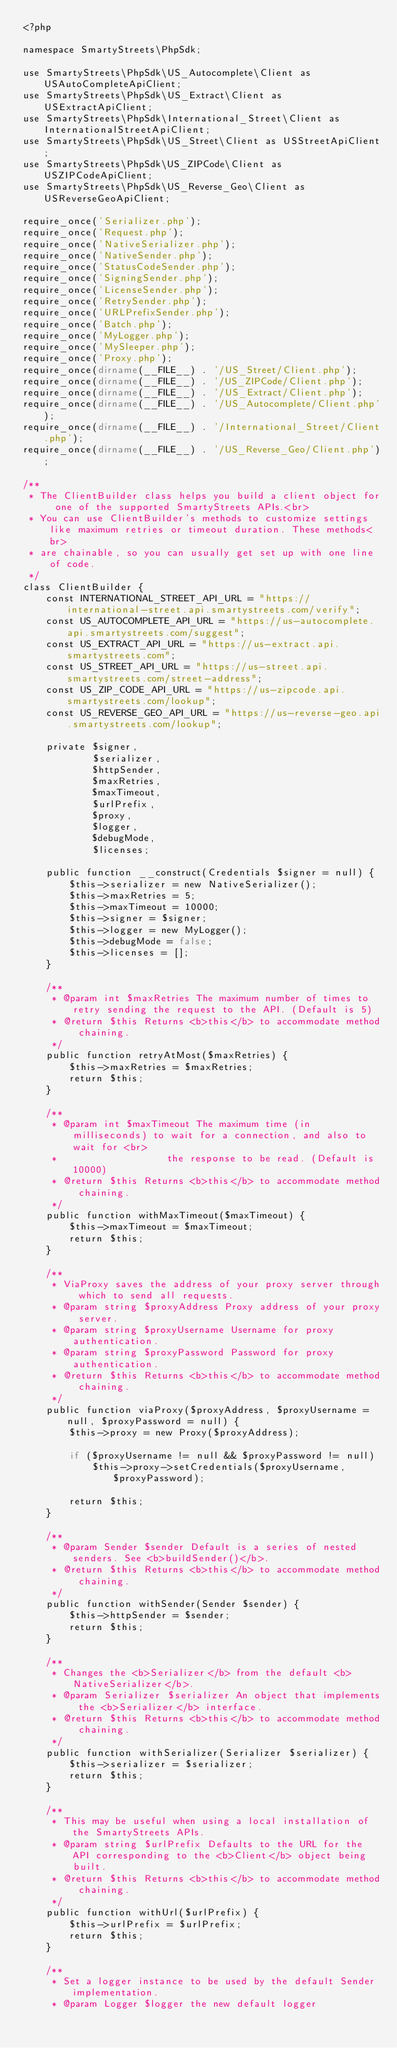Convert code to text. <code><loc_0><loc_0><loc_500><loc_500><_PHP_><?php

namespace SmartyStreets\PhpSdk;

use SmartyStreets\PhpSdk\US_Autocomplete\Client as USAutoCompleteApiClient;
use SmartyStreets\PhpSdk\US_Extract\Client as USExtractApiClient;
use SmartyStreets\PhpSdk\International_Street\Client as InternationalStreetApiClient;
use SmartyStreets\PhpSdk\US_Street\Client as USStreetApiClient;
use SmartyStreets\PhpSdk\US_ZIPCode\Client as USZIPCodeApiClient;
use SmartyStreets\PhpSdk\US_Reverse_Geo\Client as USReverseGeoApiClient;

require_once('Serializer.php');
require_once('Request.php');
require_once('NativeSerializer.php');
require_once('NativeSender.php');
require_once('StatusCodeSender.php');
require_once('SigningSender.php');
require_once('LicenseSender.php');
require_once('RetrySender.php');
require_once('URLPrefixSender.php');
require_once('Batch.php');
require_once('MyLogger.php');
require_once('MySleeper.php');
require_once('Proxy.php');
require_once(dirname(__FILE__) . '/US_Street/Client.php');
require_once(dirname(__FILE__) . '/US_ZIPCode/Client.php');
require_once(dirname(__FILE__) . '/US_Extract/Client.php');
require_once(dirname(__FILE__) . '/US_Autocomplete/Client.php');
require_once(dirname(__FILE__) . '/International_Street/Client.php');
require_once(dirname(__FILE__) . '/US_Reverse_Geo/Client.php');

/**
 * The ClientBuilder class helps you build a client object for one of the supported SmartyStreets APIs.<br>
 * You can use ClientBuilder's methods to customize settings like maximum retries or timeout duration. These methods<br>
 * are chainable, so you can usually get set up with one line of code.
 */
class ClientBuilder {
    const INTERNATIONAL_STREET_API_URL = "https://international-street.api.smartystreets.com/verify";
    const US_AUTOCOMPLETE_API_URL = "https://us-autocomplete.api.smartystreets.com/suggest";
    const US_EXTRACT_API_URL = "https://us-extract.api.smartystreets.com";
    const US_STREET_API_URL = "https://us-street.api.smartystreets.com/street-address";
    const US_ZIP_CODE_API_URL = "https://us-zipcode.api.smartystreets.com/lookup";
    const US_REVERSE_GEO_API_URL = "https://us-reverse-geo.api.smartystreets.com/lookup";

    private $signer,
            $serializer,
            $httpSender,
            $maxRetries,
            $maxTimeout,
            $urlPrefix,
            $proxy,
            $logger,
            $debugMode,
            $licenses;

    public function __construct(Credentials $signer = null) {
        $this->serializer = new NativeSerializer();
        $this->maxRetries = 5;
        $this->maxTimeout = 10000;
        $this->signer = $signer;
        $this->logger = new MyLogger();
        $this->debugMode = false;
        $this->licenses = [];
    }

    /**
     * @param int $maxRetries The maximum number of times to retry sending the request to the API. (Default is 5)
     * @return $this Returns <b>this</b> to accommodate method chaining.
     */
    public function retryAtMost($maxRetries) {
        $this->maxRetries = $maxRetries;
        return $this;
    }

    /**
     * @param int $maxTimeout The maximum time (in milliseconds) to wait for a connection, and also to wait for <br>
     *                   the response to be read. (Default is 10000)
     * @return $this Returns <b>this</b> to accommodate method chaining.
     */
    public function withMaxTimeout($maxTimeout) {
        $this->maxTimeout = $maxTimeout;
        return $this;
    }

    /**
     * ViaProxy saves the address of your proxy server through which to send all requests.
     * @param string $proxyAddress Proxy address of your proxy server.
     * @param string $proxyUsername Username for proxy authentication.
     * @param string $proxyPassword Password for proxy authentication.
     * @return $this Returns <b>this</b> to accommodate method chaining.
     */
    public function viaProxy($proxyAddress, $proxyUsername = null, $proxyPassword = null) {
        $this->proxy = new Proxy($proxyAddress);

        if ($proxyUsername != null && $proxyPassword != null)
            $this->proxy->setCredentials($proxyUsername, $proxyPassword);

        return $this;
    }

    /**
     * @param Sender $sender Default is a series of nested senders. See <b>buildSender()</b>.
     * @return $this Returns <b>this</b> to accommodate method chaining.
     */
    public function withSender(Sender $sender) {
        $this->httpSender = $sender;
        return $this;
    }

    /**
     * Changes the <b>Serializer</b> from the default <b>NativeSerializer</b>.
     * @param Serializer $serializer An object that implements the <b>Serializer</b> interface.
     * @return $this Returns <b>this</b> to accommodate method chaining.
     */
    public function withSerializer(Serializer $serializer) {
        $this->serializer = $serializer;
        return $this;
    }

    /**
     * This may be useful when using a local installation of the SmartyStreets APIs.
     * @param string $urlPrefix Defaults to the URL for the API corresponding to the <b>Client</b> object being built.
     * @return $this Returns <b>this</b> to accommodate method chaining.
     */
    public function withUrl($urlPrefix) {
        $this->urlPrefix = $urlPrefix;
        return $this;
    }

    /**
     * Set a logger instance to be used by the default Sender implementation.
     * @param Logger $logger the new default logger</code> 